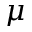<formula> <loc_0><loc_0><loc_500><loc_500>\mu</formula> 